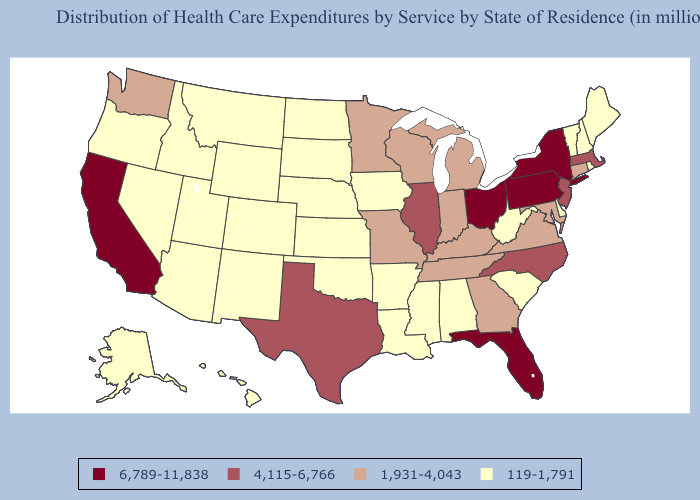Does Florida have the lowest value in the South?
Be succinct. No. What is the highest value in the USA?
Write a very short answer. 6,789-11,838. Does Florida have the highest value in the South?
Be succinct. Yes. What is the value of Virginia?
Write a very short answer. 1,931-4,043. What is the lowest value in the Northeast?
Answer briefly. 119-1,791. What is the highest value in states that border South Carolina?
Keep it brief. 4,115-6,766. Does Ohio have the highest value in the MidWest?
Give a very brief answer. Yes. Does California have the highest value in the West?
Concise answer only. Yes. Is the legend a continuous bar?
Be succinct. No. Name the states that have a value in the range 6,789-11,838?
Be succinct. California, Florida, New York, Ohio, Pennsylvania. Name the states that have a value in the range 4,115-6,766?
Keep it brief. Illinois, Massachusetts, New Jersey, North Carolina, Texas. Name the states that have a value in the range 4,115-6,766?
Short answer required. Illinois, Massachusetts, New Jersey, North Carolina, Texas. How many symbols are there in the legend?
Answer briefly. 4. Does Utah have a lower value than Maryland?
Answer briefly. Yes. Name the states that have a value in the range 4,115-6,766?
Quick response, please. Illinois, Massachusetts, New Jersey, North Carolina, Texas. 